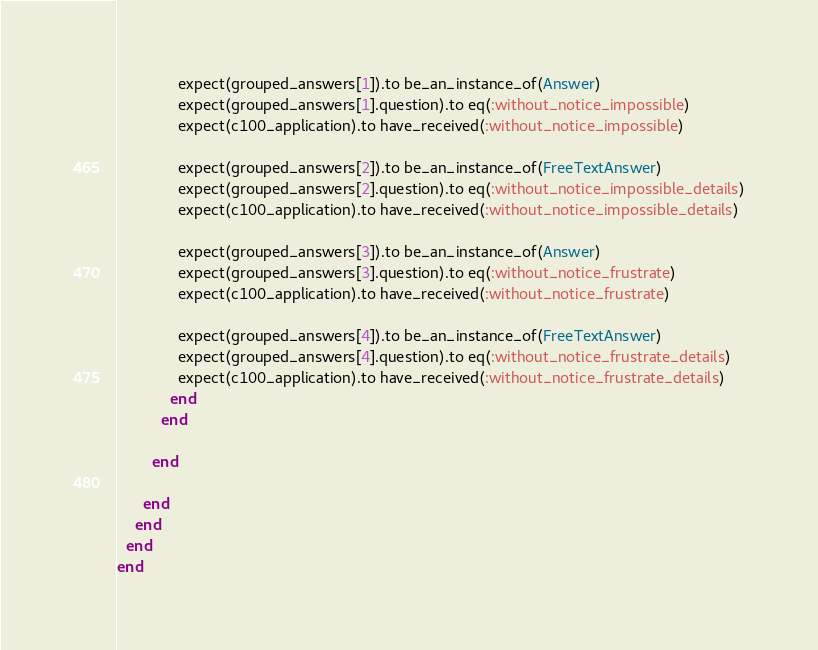Convert code to text. <code><loc_0><loc_0><loc_500><loc_500><_Ruby_>              expect(grouped_answers[1]).to be_an_instance_of(Answer)
              expect(grouped_answers[1].question).to eq(:without_notice_impossible)
              expect(c100_application).to have_received(:without_notice_impossible)

              expect(grouped_answers[2]).to be_an_instance_of(FreeTextAnswer)
              expect(grouped_answers[2].question).to eq(:without_notice_impossible_details)
              expect(c100_application).to have_received(:without_notice_impossible_details)

              expect(grouped_answers[3]).to be_an_instance_of(Answer)
              expect(grouped_answers[3].question).to eq(:without_notice_frustrate)
              expect(c100_application).to have_received(:without_notice_frustrate)

              expect(grouped_answers[4]).to be_an_instance_of(FreeTextAnswer)
              expect(grouped_answers[4].question).to eq(:without_notice_frustrate_details)
              expect(c100_application).to have_received(:without_notice_frustrate_details)
            end
          end

        end

      end
    end
  end
end
</code> 